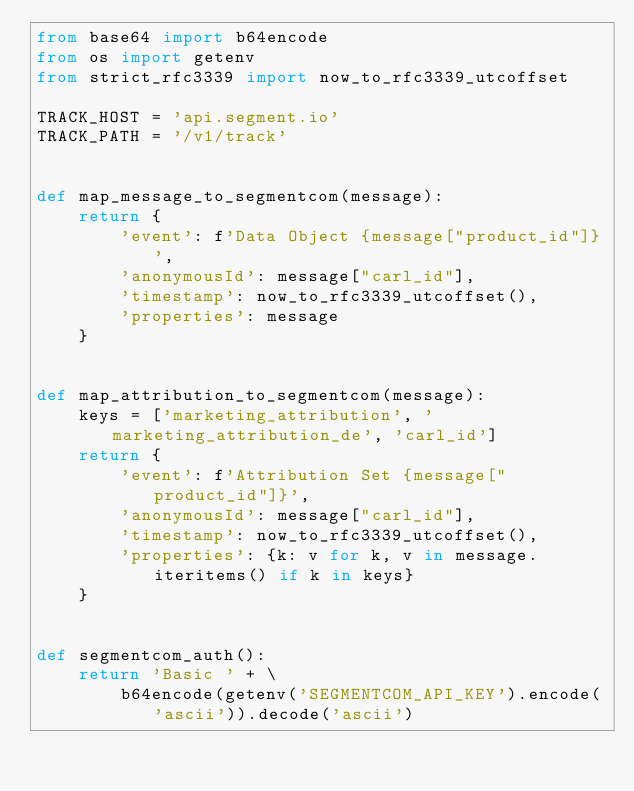Convert code to text. <code><loc_0><loc_0><loc_500><loc_500><_Python_>from base64 import b64encode
from os import getenv
from strict_rfc3339 import now_to_rfc3339_utcoffset

TRACK_HOST = 'api.segment.io'
TRACK_PATH = '/v1/track'


def map_message_to_segmentcom(message):
    return {
        'event': f'Data Object {message["product_id"]}',
        'anonymousId': message["carl_id"],
        'timestamp': now_to_rfc3339_utcoffset(),
        'properties': message
    }


def map_attribution_to_segmentcom(message):
    keys = ['marketing_attribution', 'marketing_attribution_de', 'carl_id']
    return {
        'event': f'Attribution Set {message["product_id"]}',
        'anonymousId': message["carl_id"],
        'timestamp': now_to_rfc3339_utcoffset(),
        'properties': {k: v for k, v in message.iteritems() if k in keys}
    }


def segmentcom_auth():
    return 'Basic ' + \
        b64encode(getenv('SEGMENTCOM_API_KEY').encode('ascii')).decode('ascii')
</code> 